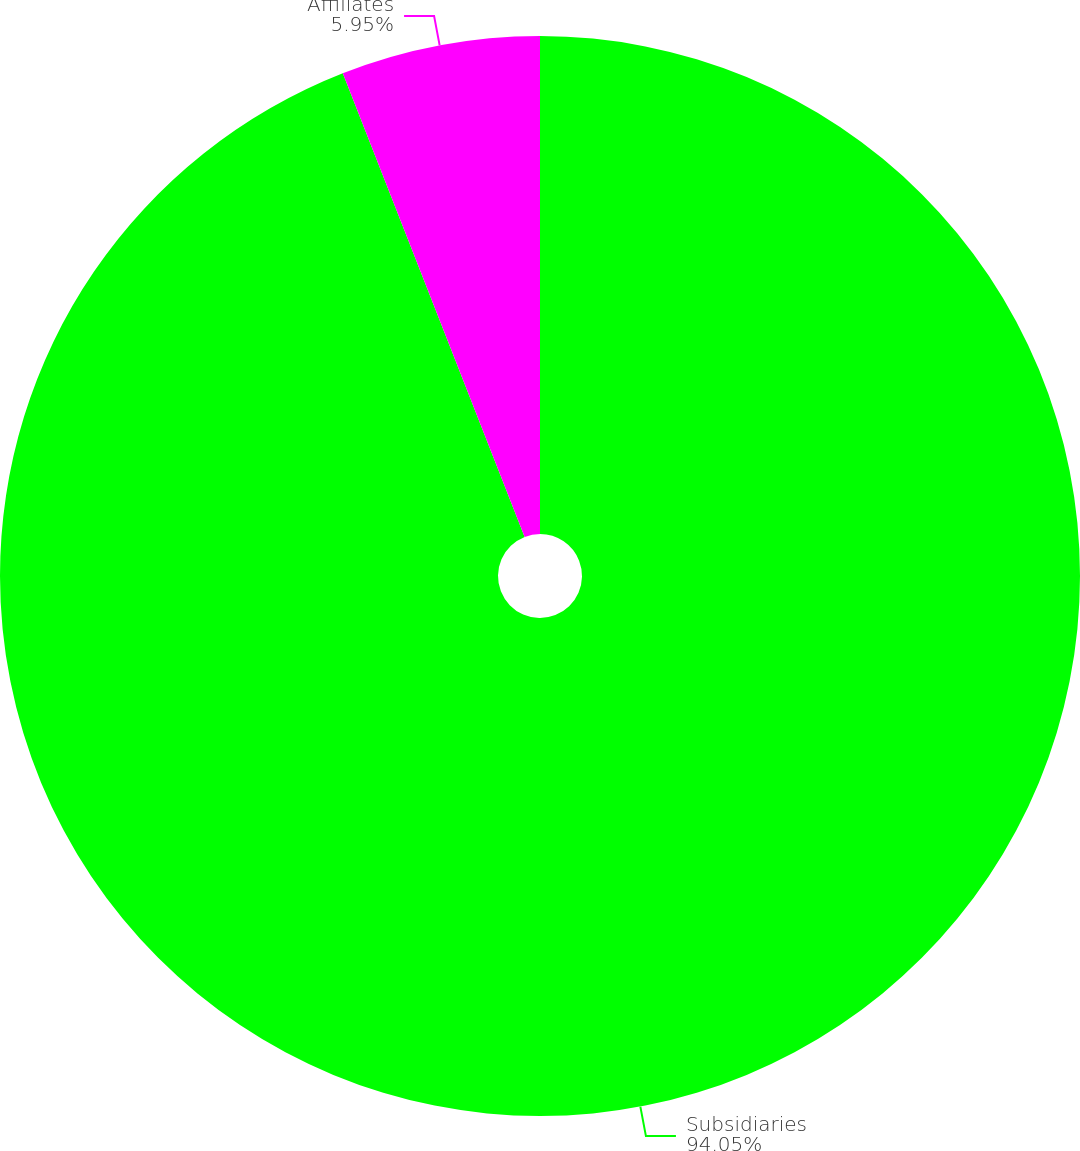<chart> <loc_0><loc_0><loc_500><loc_500><pie_chart><fcel>Subsidiaries<fcel>Affiliates<nl><fcel>94.05%<fcel>5.95%<nl></chart> 